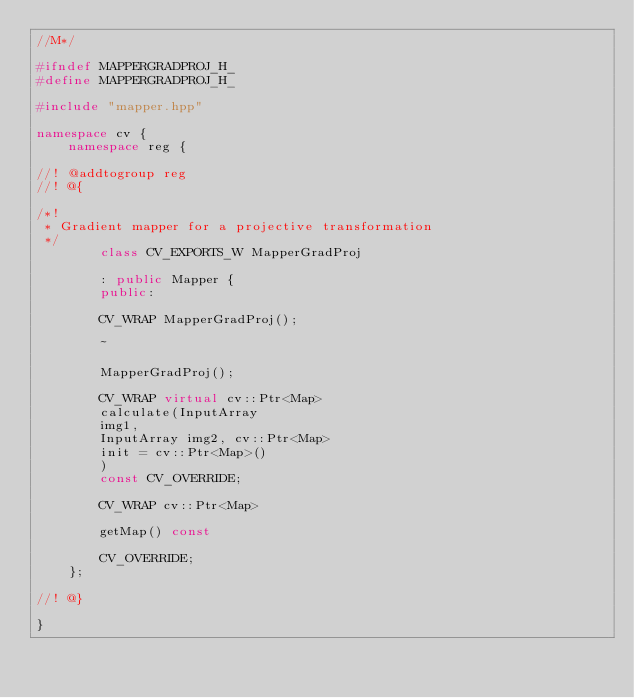Convert code to text. <code><loc_0><loc_0><loc_500><loc_500><_C++_>//M*/

#ifndef MAPPERGRADPROJ_H_
#define MAPPERGRADPROJ_H_

#include "mapper.hpp"

namespace cv {
    namespace reg {

//! @addtogroup reg
//! @{

/*!
 * Gradient mapper for a projective transformation
 */
        class CV_EXPORTS_W MapperGradProj

        : public Mapper {
        public:

        CV_WRAP MapperGradProj();

        ~

        MapperGradProj();

        CV_WRAP virtual cv::Ptr<Map>
        calculate(InputArray
        img1,
        InputArray img2, cv::Ptr<Map>
        init = cv::Ptr<Map>()
        )
        const CV_OVERRIDE;

        CV_WRAP cv::Ptr<Map>

        getMap() const

        CV_OVERRIDE;
    };

//! @}

}</code> 